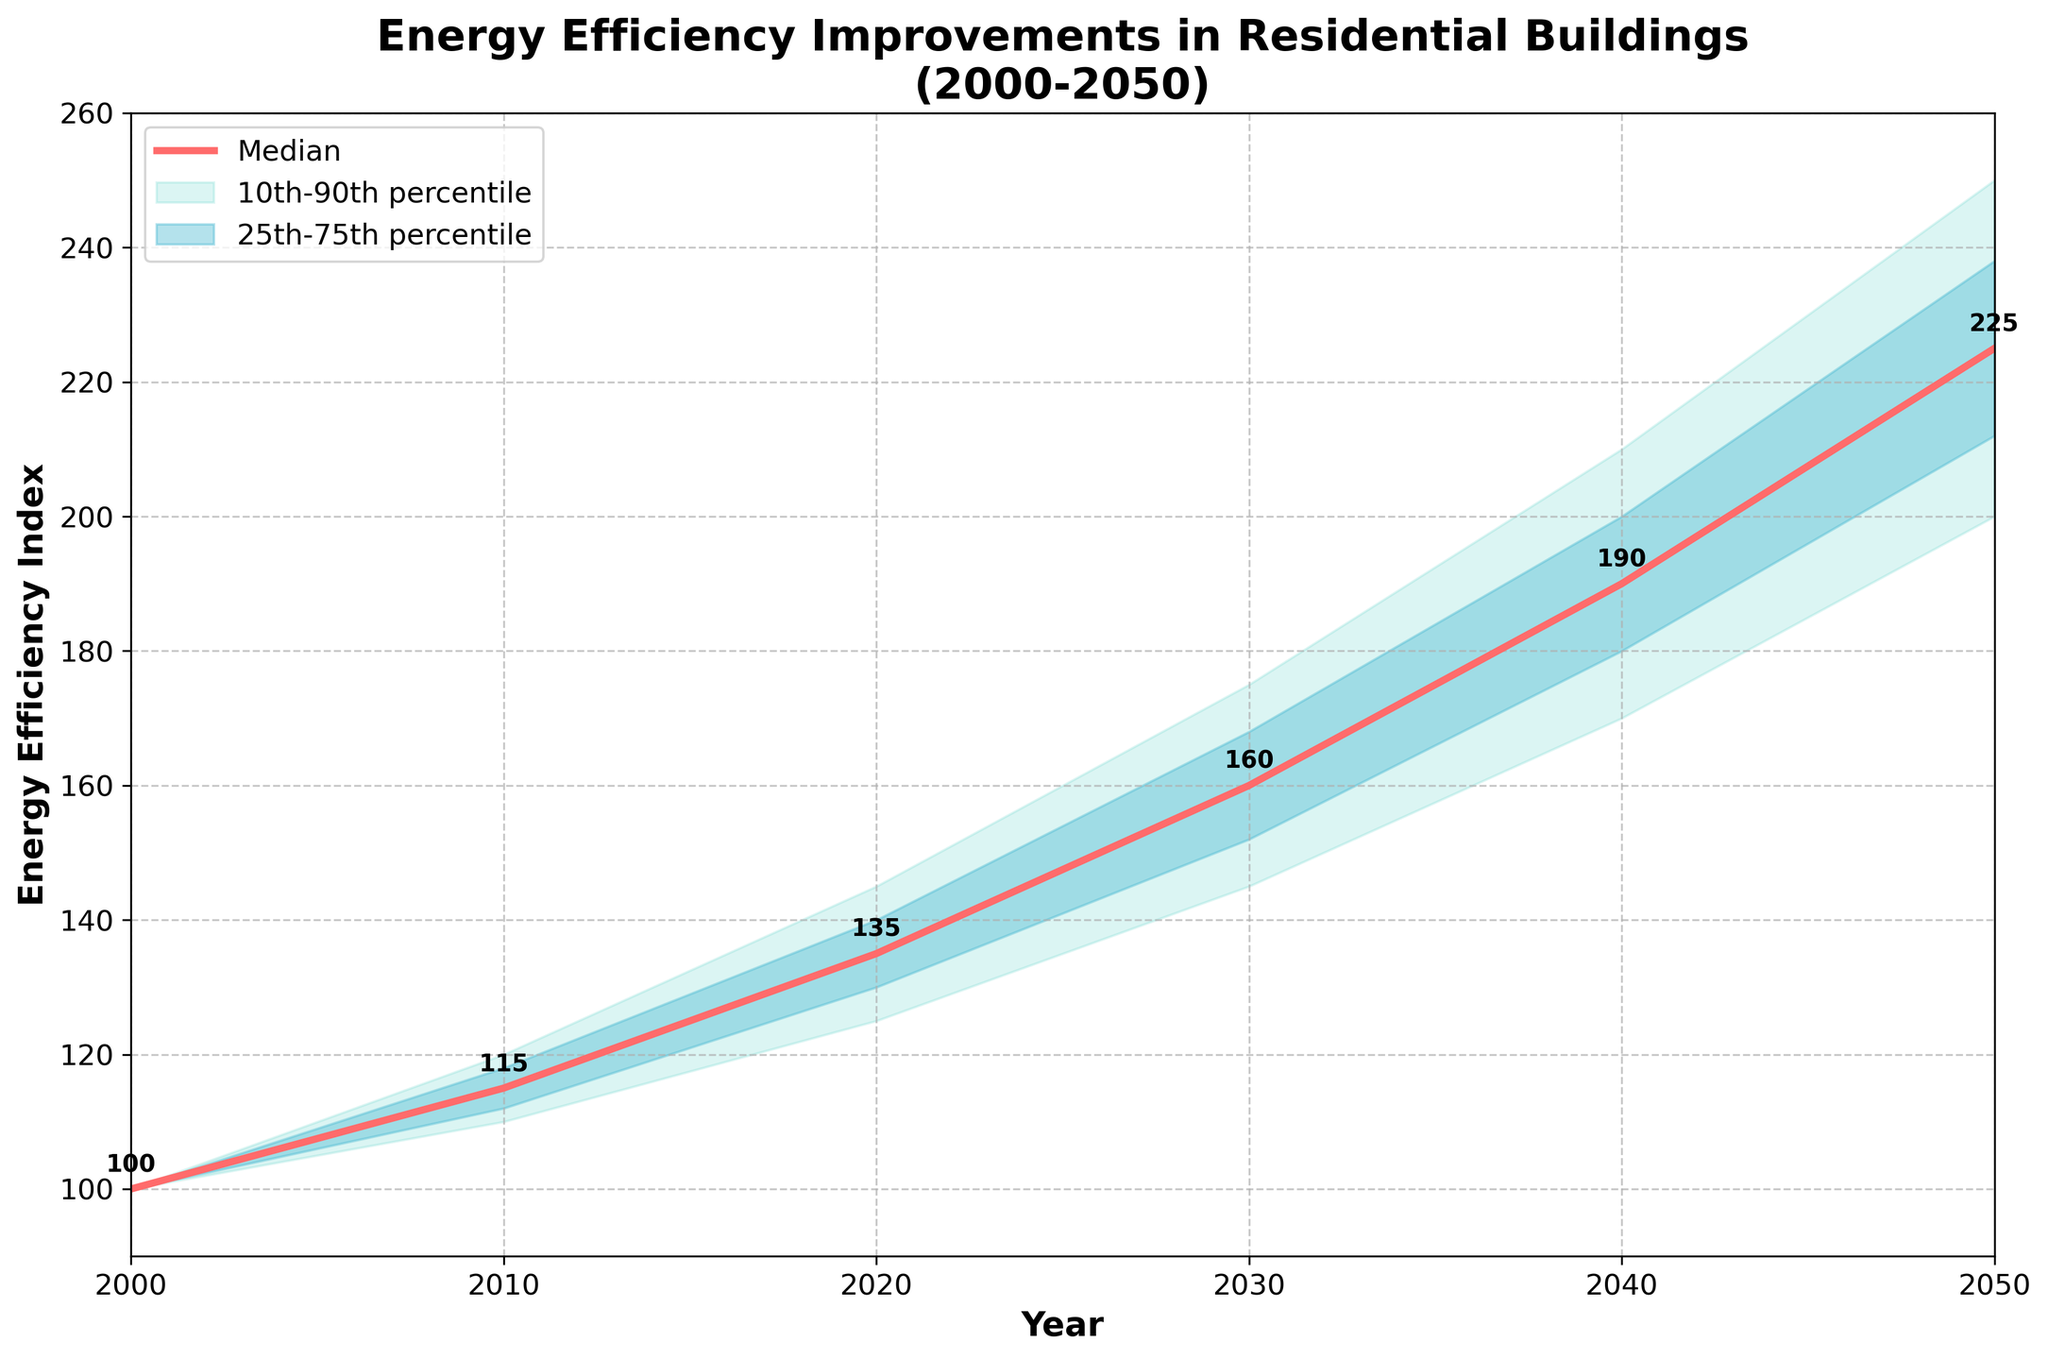what is the highest percentile represented on the chart? The highest percentile represented on the chart is the upper 90th percentile, which is the upper boundary of the shaded area with the lightest color.
Answer: upper 90th percentile How much does the median value increase from 2000 to 2050? The median values for 2000 and 2050 are 100 and 225, respectively. The increase is calculated by subtracting the 2000 value from the 2050 value (225 - 100).
Answer: 125 In which year does the median value reach 190? The median value reaches 190 in the year 2040, according to the annotations next to the median line.
Answer: 2040 How does the interquartile range (25th to 75th percentile) change from 2000 to 2050? The 25th percentile in 2000 is 100 and the 75th percentile is also 100. In 2050, the 25th percentile is 212 and the 75th percentile is 238. The interquartile range changes from 0 (100 - 100) in 2000 to 26 (238 - 212) in 2050.
Answer: increases by 26 Which decade shows the largest increase in the median value? To identify the decade with the largest median increase, we compare the differences between consecutive decades. \
Median values: 2010 - 2000 (115 - 100 = 15), 2020 - 2010 (135 - 115 = 20), 2030 - 2020 (160 - 135 = 25), 2040 - 2030 (190 - 160 = 30), and 2050 - 2040 (225 - 190 = 35). The largest increase occurs between 2040 and 2050.
Answer: 2040 to 2050 Which data point shows the highest value within the 90th percentile range? The 90th percentile values are given for each year in the data. The highest 90th percentile value is 250, which appears in the year 2050.
Answer: 250 in 2050 What is the range of energy efficiency values for the year 2030? In the year 2030, the 10th percentile value is 145 and the 90th percentile value is 175. The range is calculated by subtracting the 10th percentile from the 90th percentile (175 - 145).
Answer: 30 How many years does it take for the median value to double from its value in 2000? The median value in 2000 is 100. The median value doubles to 200. According to the data, the median value reaches 200 between 2040 (190) and 2050 (225). Hence, it takes between 40 to 50 years for the value to approximately double.
Answer: around 50 years What trend is observed in energy efficiency improvements from 2000 to 2050? Observing the data from 2000 to 2050, the median energy efficiency index increases steadily from 100 in 2000 to 225 in 2050. Both the lower and upper percentiles also show an increasing trend, indicating that overall energy efficiency in residential buildings improves significantly over this period.
Answer: increasing trend 